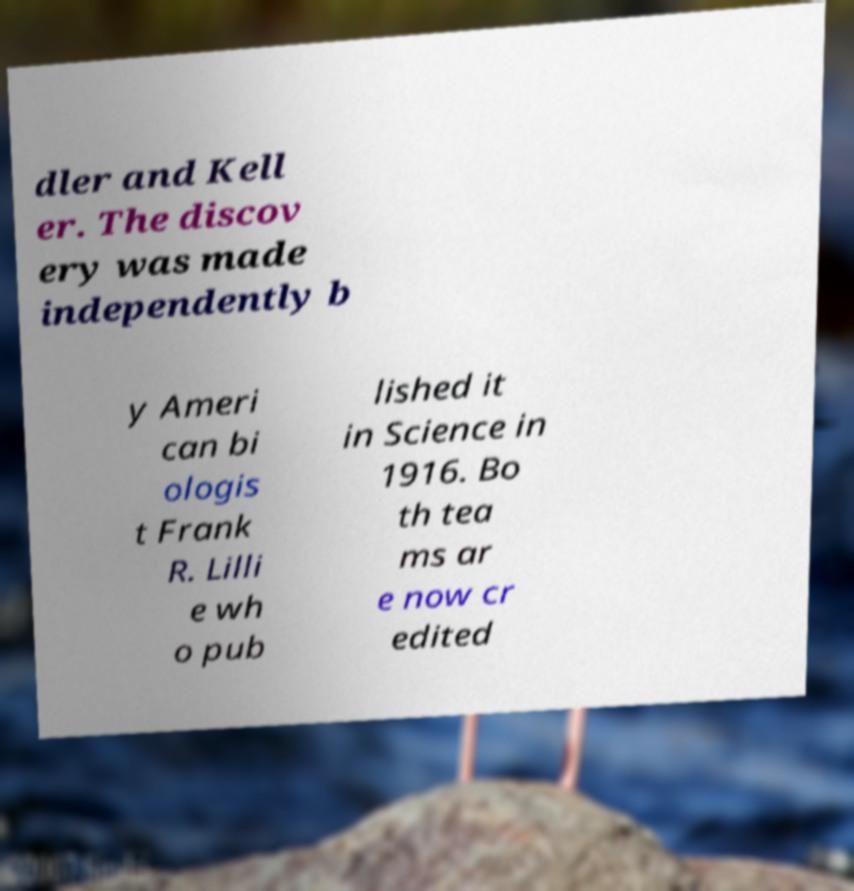Please identify and transcribe the text found in this image. dler and Kell er. The discov ery was made independently b y Ameri can bi ologis t Frank R. Lilli e wh o pub lished it in Science in 1916. Bo th tea ms ar e now cr edited 